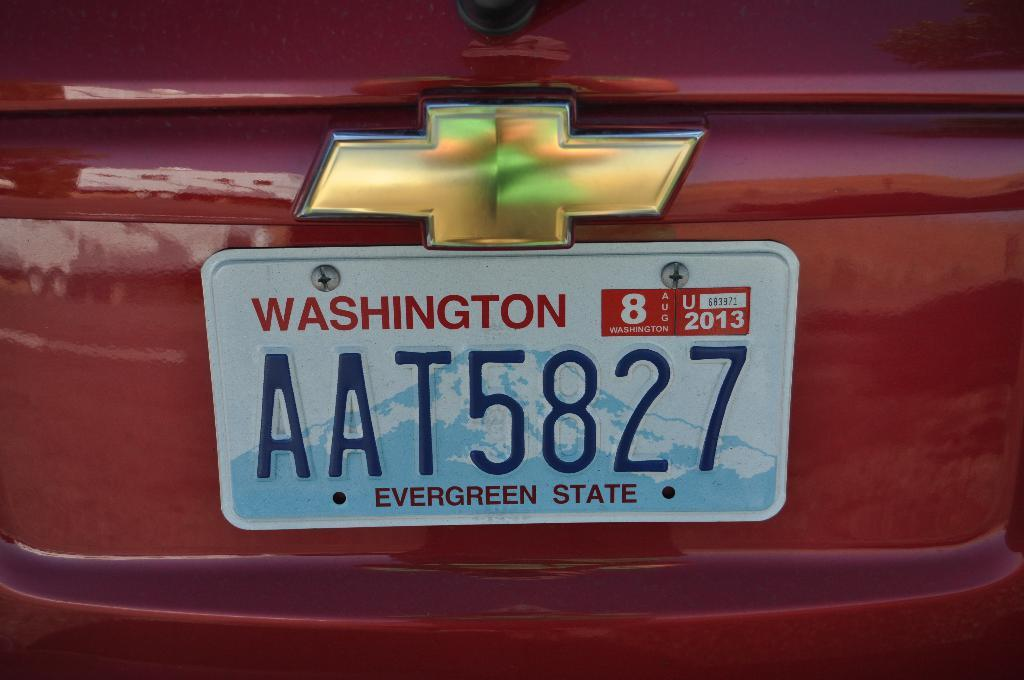<image>
Offer a succinct explanation of the picture presented. A red Chevrolet rear with a WASHINGTON license plate AAT5827. 